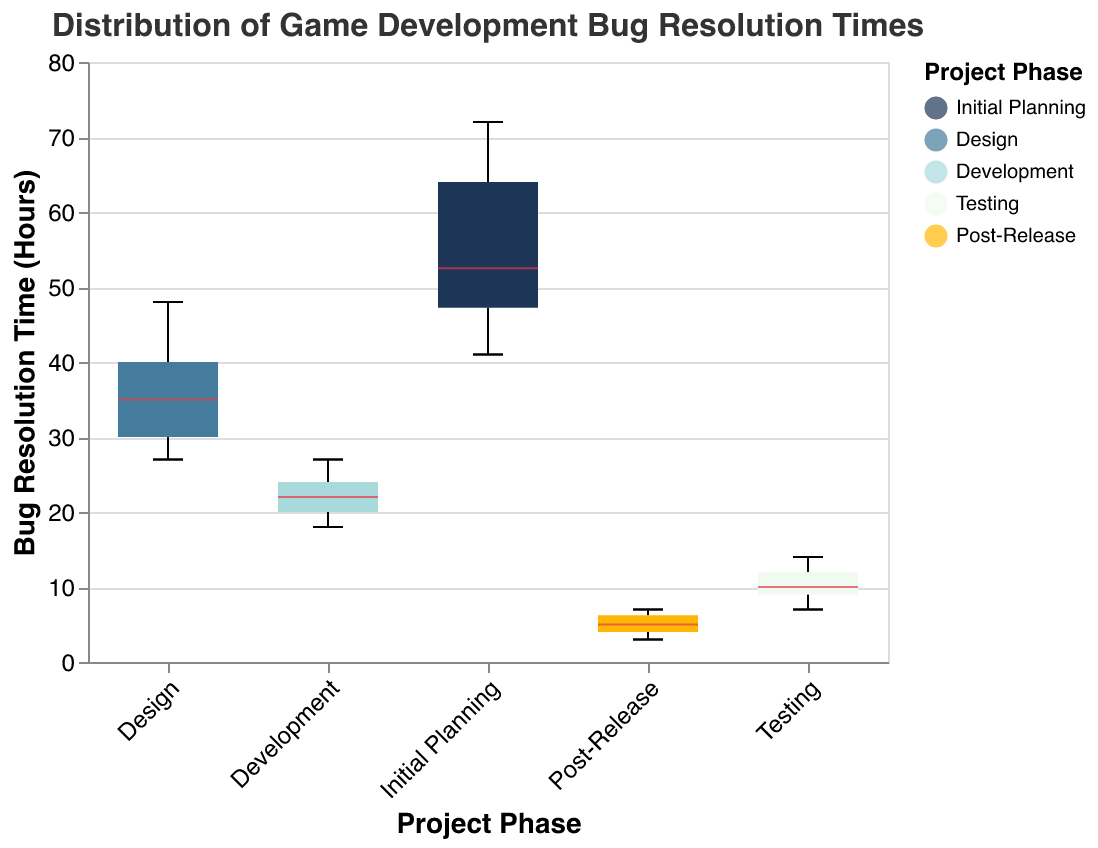What is the median bug resolution time during the Initial Planning phase? The median value of a box plot is represented by the line inside the box. For the Initial Planning phase, locate the central line within the box to determine the median.
Answer: 52.5 Which project phase has the lowest median bug resolution time? Compare the central lines inside the boxes for each phase. The Post-Release phase has the lowest median.
Answer: Post-Release Does the Development phase have a higher median bug resolution time compared to the Testing phase? Check the central lines within the boxes representing Development and Testing. The Development phase has a higher median line than the Testing phase.
Answer: Yes What is the range of bug resolution times during the Testing phase? Identify the lowest and highest points within the whiskers for the Testing phase. The lowest is 7, and the highest is 14. The range is 14 - 7.
Answer: 7 In which phase do we see the widest distribution of bug resolution times? Evaluate the length of the boxes and whiskers to determine the widest distribution. The Initial Planning phase shows the widest distribution.
Answer: Initial Planning Compare the interquartile ranges (IQRs) of the Development and Design phases. Which has a narrower IQR? The IQR is represented by the length of the box. The Development phase box is narrower compared to the Design phase box.
Answer: Development How does the median bug resolution time in the Design phase compare to that in the Initial Planning phase? Compare the central lines in the boxes for both phases. The median in the Design phase is lower than that in the Initial Planning phase.
Answer: Lower How many project phases show a median bug resolution time of 10 hours or less? Identify the central lines in each box. The Testing and Post-Release phases show medians of 10 hours or less.
Answer: 2 Which phase has the smallest IQR, and what does this suggest about the variability of bug resolution times in that phase? Identify the phase with the shortest box. The Post-Release phase has the smallest IQR, suggesting it has the least variability in bug resolution times.
Answer: Post-Release, least variability Are there any phases where the bug resolution times overlap significantly with another phase? Locate the notches on the box plots which indicate the confidence intervals around the medians. The Design and Development phases have overlapping notches, indicating significant overlap in bug resolution times.
Answer: Design and Development 